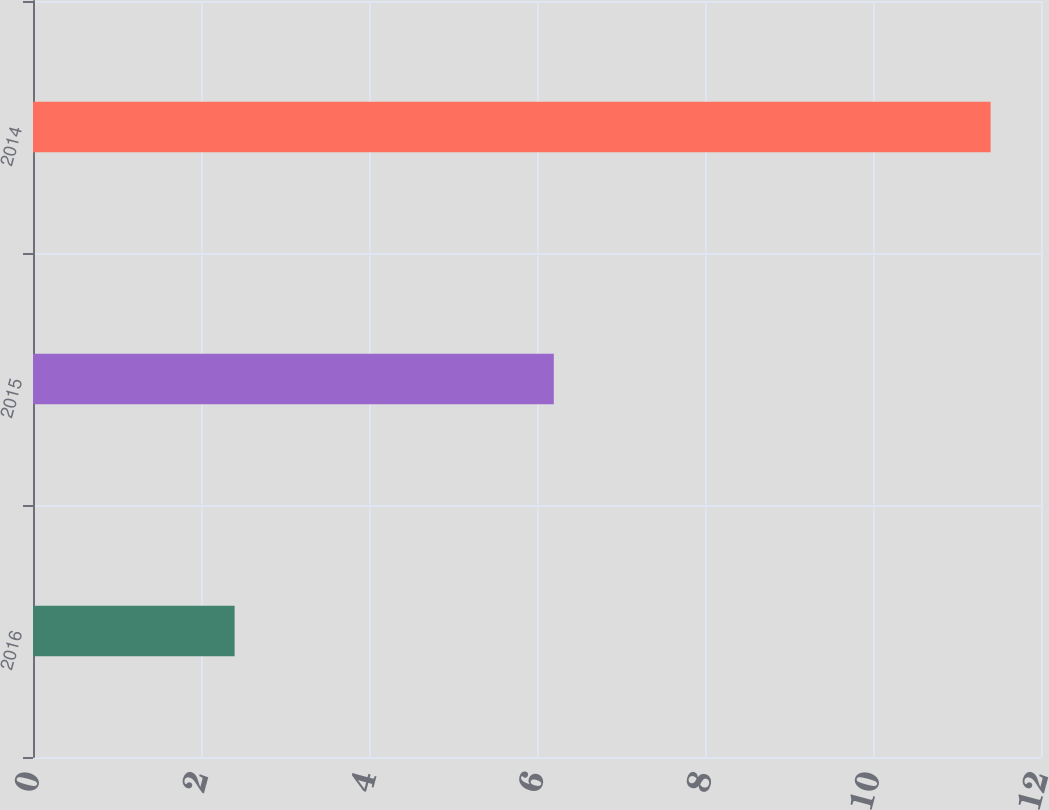<chart> <loc_0><loc_0><loc_500><loc_500><bar_chart><fcel>2016<fcel>2015<fcel>2014<nl><fcel>2.4<fcel>6.2<fcel>11.4<nl></chart> 